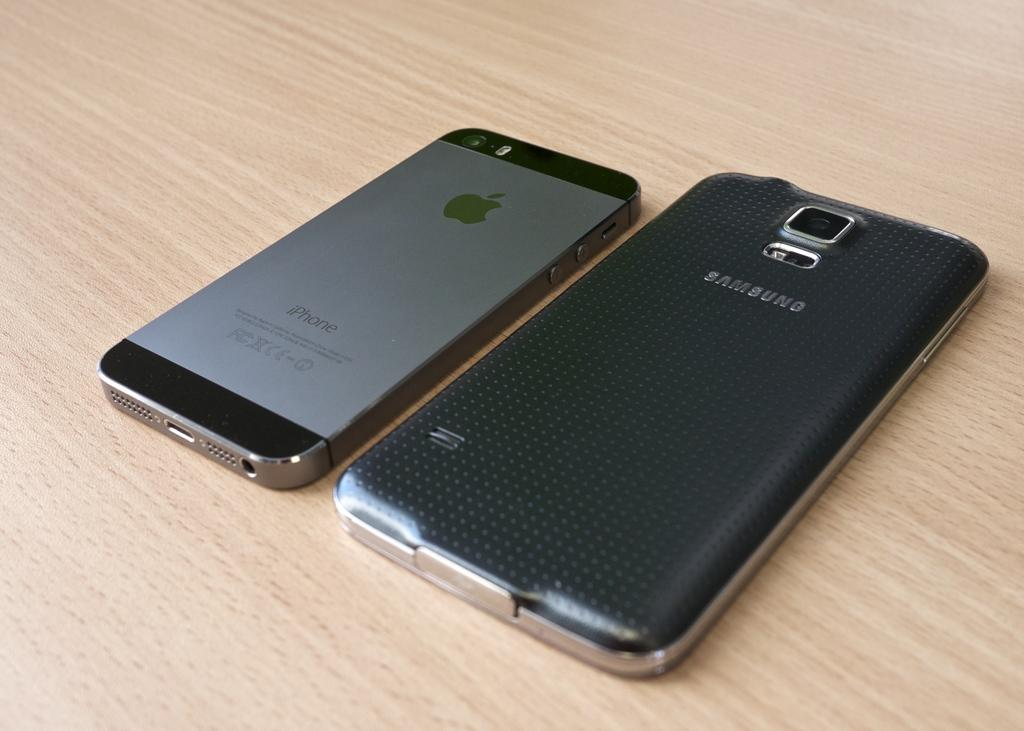<image>
Summarize the visual content of the image. A Samsung phone and an Apple iPhone are laying on a wood surface. 